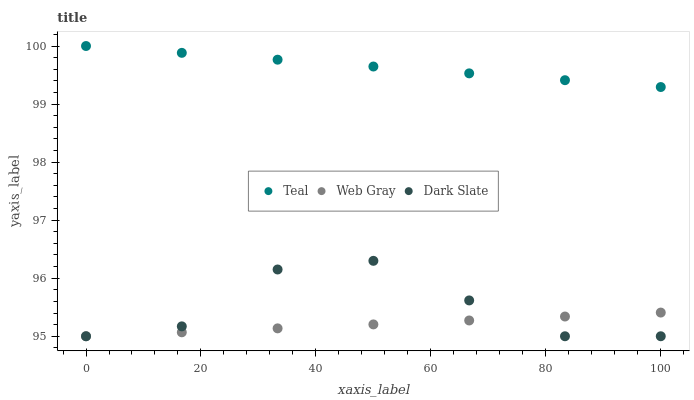Does Web Gray have the minimum area under the curve?
Answer yes or no. Yes. Does Teal have the maximum area under the curve?
Answer yes or no. Yes. Does Teal have the minimum area under the curve?
Answer yes or no. No. Does Web Gray have the maximum area under the curve?
Answer yes or no. No. Is Web Gray the smoothest?
Answer yes or no. Yes. Is Dark Slate the roughest?
Answer yes or no. Yes. Is Teal the smoothest?
Answer yes or no. No. Is Teal the roughest?
Answer yes or no. No. Does Dark Slate have the lowest value?
Answer yes or no. Yes. Does Teal have the lowest value?
Answer yes or no. No. Does Teal have the highest value?
Answer yes or no. Yes. Does Web Gray have the highest value?
Answer yes or no. No. Is Dark Slate less than Teal?
Answer yes or no. Yes. Is Teal greater than Web Gray?
Answer yes or no. Yes. Does Dark Slate intersect Web Gray?
Answer yes or no. Yes. Is Dark Slate less than Web Gray?
Answer yes or no. No. Is Dark Slate greater than Web Gray?
Answer yes or no. No. Does Dark Slate intersect Teal?
Answer yes or no. No. 